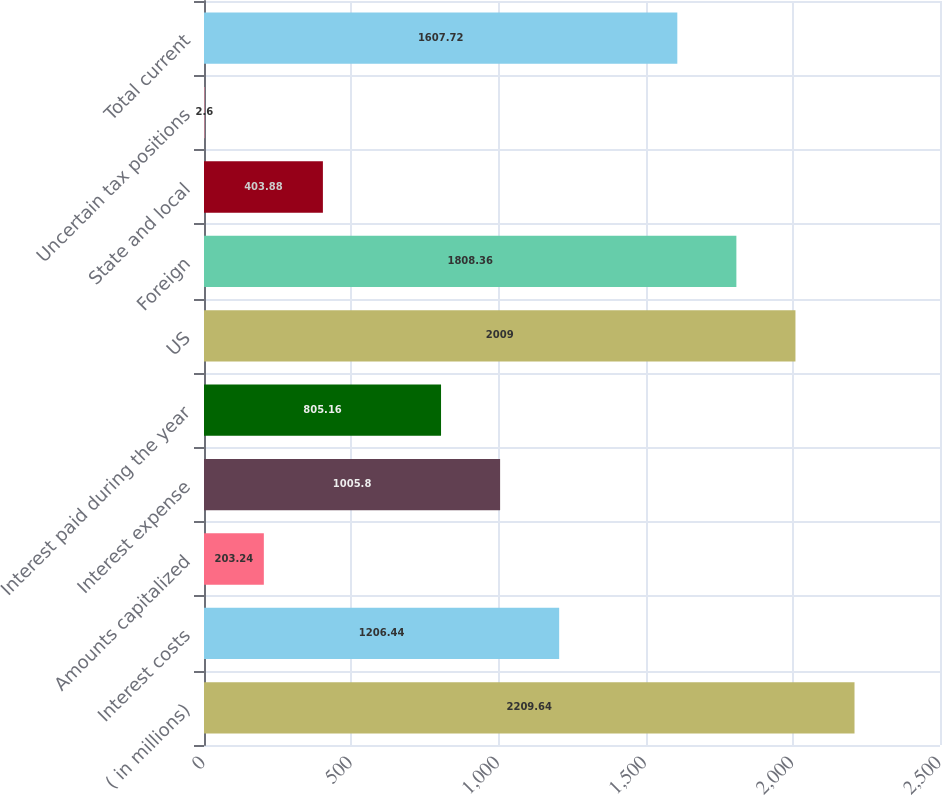Convert chart to OTSL. <chart><loc_0><loc_0><loc_500><loc_500><bar_chart><fcel>( in millions)<fcel>Interest costs<fcel>Amounts capitalized<fcel>Interest expense<fcel>Interest paid during the year<fcel>US<fcel>Foreign<fcel>State and local<fcel>Uncertain tax positions<fcel>Total current<nl><fcel>2209.64<fcel>1206.44<fcel>203.24<fcel>1005.8<fcel>805.16<fcel>2009<fcel>1808.36<fcel>403.88<fcel>2.6<fcel>1607.72<nl></chart> 